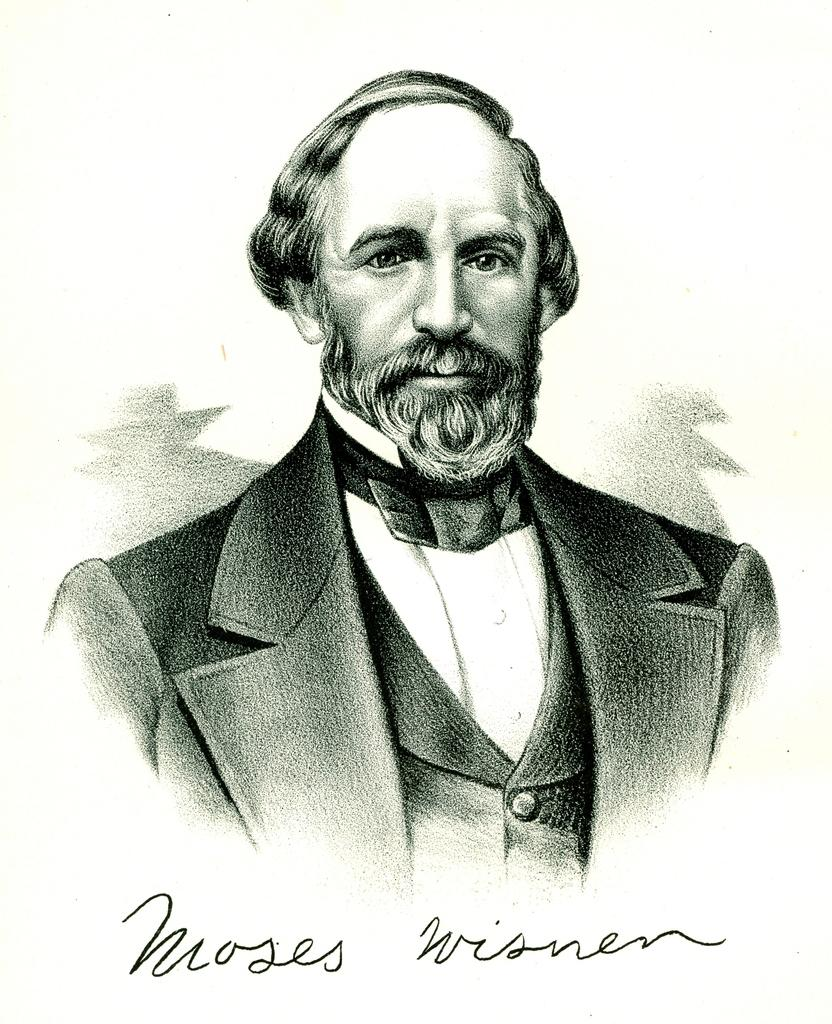What is the main subject of the image? The main subject of the image is a sketch of a person. Is there any text present in the image? Yes, there is text written in the image. What type of vegetable is being used to draw the sketch in the image? There is no vegetable present in the image; it is a sketch drawn with a pen or pencil, not a vegetable. 